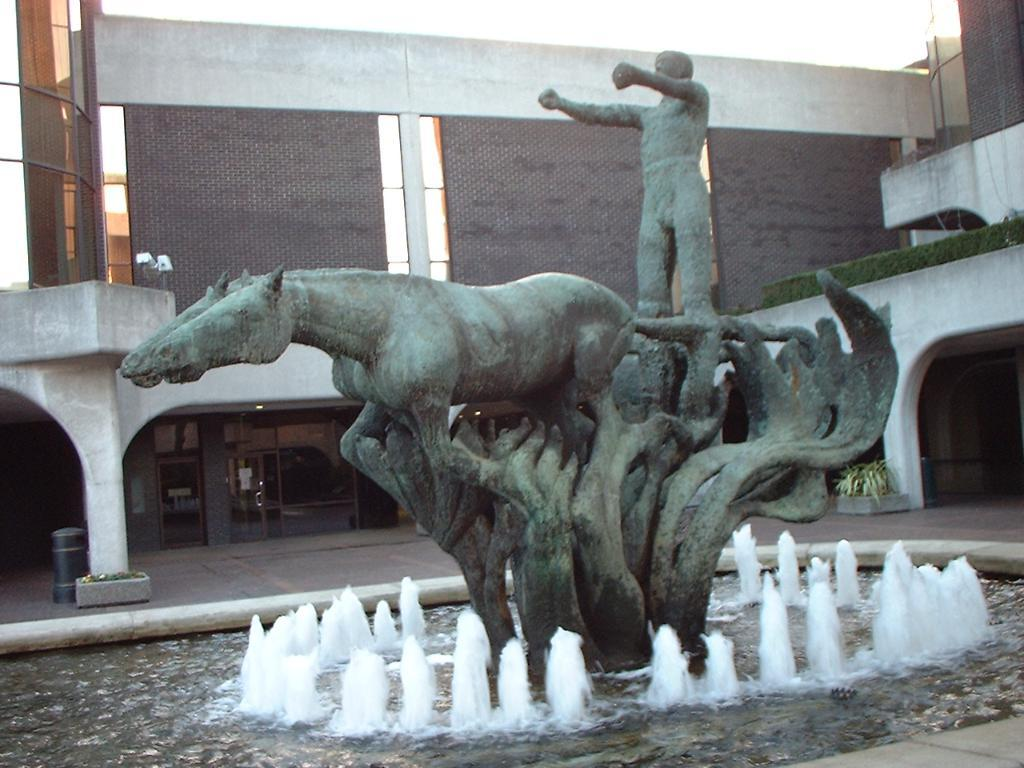What is the main subject in the center of the image? There is a statue in the center of the image. What is present in the image besides the statue? There is water in the image. What can be seen in the background of the image? There is a building, a wall, glass, a dustbin, plants, pillars, and a few other objects in the background of the image. How many times does the statue jump in the image? The statue does not jump in the image; it is a stationary object. What type of grain is present in the image? There is no grain present in the image. 